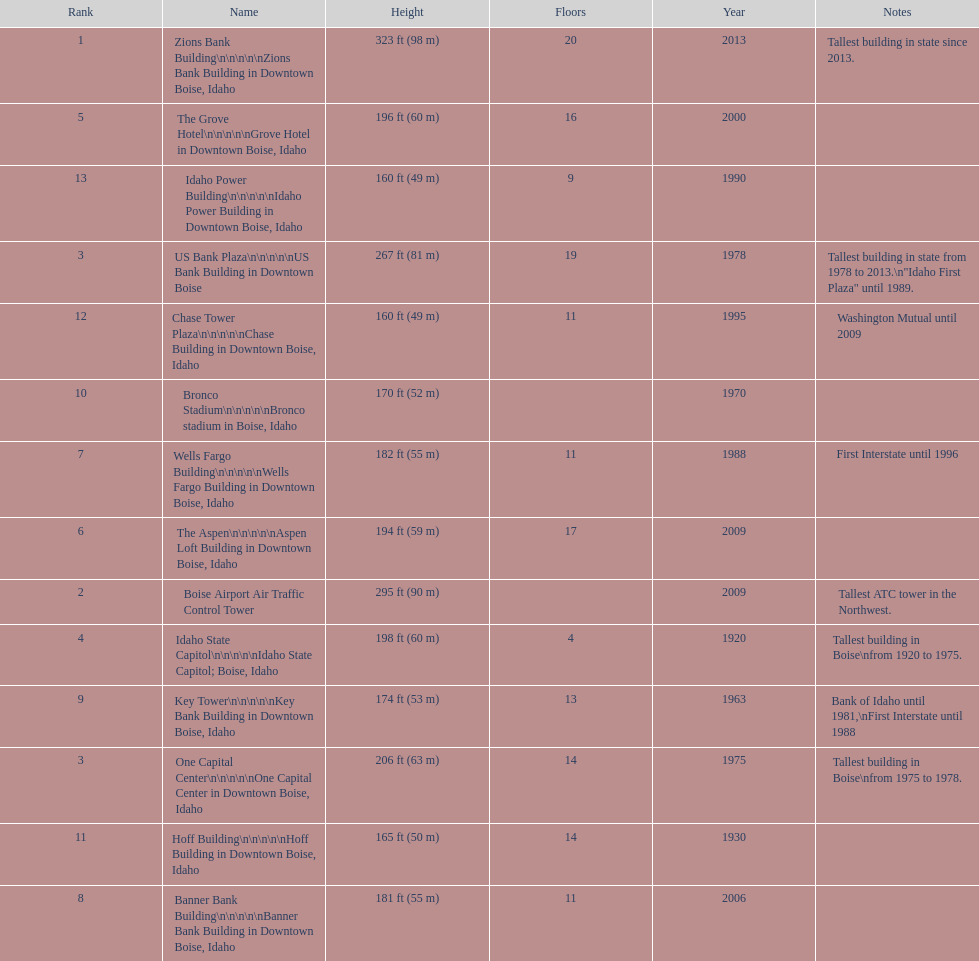Would you be able to parse every entry in this table? {'header': ['Rank', 'Name', 'Height', 'Floors', 'Year', 'Notes'], 'rows': [['1', 'Zions Bank Building\\n\\n\\n\\n\\nZions Bank Building in Downtown Boise, Idaho', '323\xa0ft (98\xa0m)', '20', '2013', 'Tallest building in state since 2013.'], ['5', 'The Grove Hotel\\n\\n\\n\\n\\nGrove Hotel in Downtown Boise, Idaho', '196\xa0ft (60\xa0m)', '16', '2000', ''], ['13', 'Idaho Power Building\\n\\n\\n\\n\\nIdaho Power Building in Downtown Boise, Idaho', '160\xa0ft (49\xa0m)', '9', '1990', ''], ['3', 'US Bank Plaza\\n\\n\\n\\n\\nUS Bank Building in Downtown Boise', '267\xa0ft (81\xa0m)', '19', '1978', 'Tallest building in state from 1978 to 2013.\\n"Idaho First Plaza" until 1989.'], ['12', 'Chase Tower Plaza\\n\\n\\n\\n\\nChase Building in Downtown Boise, Idaho', '160\xa0ft (49\xa0m)', '11', '1995', 'Washington Mutual until 2009'], ['10', 'Bronco Stadium\\n\\n\\n\\n\\nBronco stadium in Boise, Idaho', '170\xa0ft (52\xa0m)', '', '1970', ''], ['7', 'Wells Fargo Building\\n\\n\\n\\n\\nWells Fargo Building in Downtown Boise, Idaho', '182\xa0ft (55\xa0m)', '11', '1988', 'First Interstate until 1996'], ['6', 'The Aspen\\n\\n\\n\\n\\nAspen Loft Building in Downtown Boise, Idaho', '194\xa0ft (59\xa0m)', '17', '2009', ''], ['2', 'Boise Airport Air Traffic Control Tower', '295\xa0ft (90\xa0m)', '', '2009', 'Tallest ATC tower in the Northwest.'], ['4', 'Idaho State Capitol\\n\\n\\n\\n\\nIdaho State Capitol; Boise, Idaho', '198\xa0ft (60\xa0m)', '4', '1920', 'Tallest building in Boise\\nfrom 1920 to 1975.'], ['9', 'Key Tower\\n\\n\\n\\n\\nKey Bank Building in Downtown Boise, Idaho', '174\xa0ft (53\xa0m)', '13', '1963', 'Bank of Idaho until 1981,\\nFirst Interstate until 1988'], ['3', 'One Capital Center\\n\\n\\n\\n\\nOne Capital Center in Downtown Boise, Idaho', '206\xa0ft (63\xa0m)', '14', '1975', 'Tallest building in Boise\\nfrom 1975 to 1978.'], ['11', 'Hoff Building\\n\\n\\n\\n\\nHoff Building in Downtown Boise, Idaho', '165\xa0ft (50\xa0m)', '14', '1930', ''], ['8', 'Banner Bank Building\\n\\n\\n\\n\\nBanner Bank Building in Downtown Boise, Idaho', '181\xa0ft (55\xa0m)', '11', '2006', '']]} Which building has the most floors according to this chart? Zions Bank Building. 